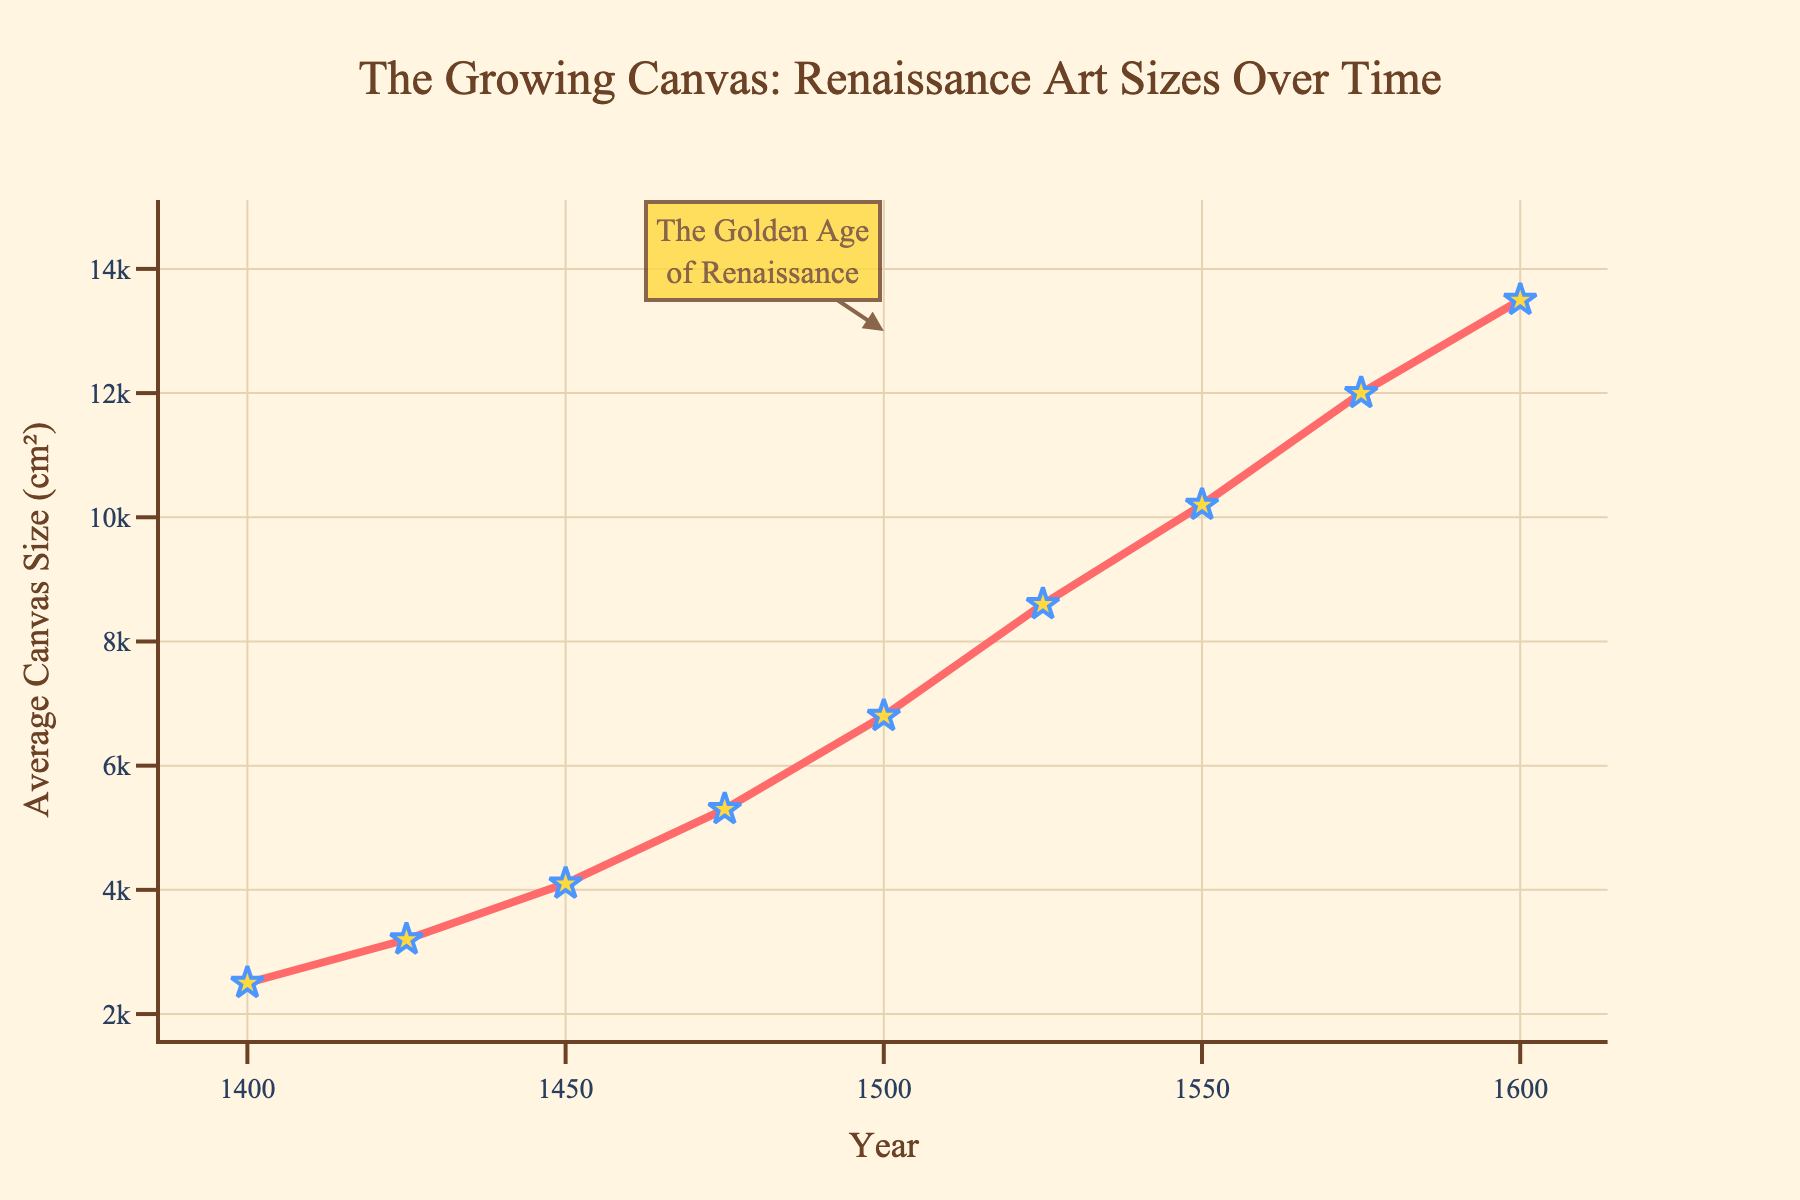What is the average canvas size in 1475? Check the data point on the line chart corresponding to the year 1475, which shows an average canvas size of 5300 cm².
Answer: 5300 cm² How much did the average canvas size increase between 1450 and 1500? Locate the data points for 1450 and 1500 in the chart. For 1450, the average size is 4100 cm²; for 1500, it is 6800 cm². Subtract the value of 1450 from 1500: 6800 - 4100 = 2700 cm².
Answer: 2700 cm² In what year did the average canvas size first exceed 8000 cm²? Scan the chart to identify the year where the average canvas size first crosses 8000 cm². It's between 1500 (6800 cm²) and 1525 (8600 cm²). Therefore, the year is 1525.
Answer: 1525 What was the difference in average canvas size from the beginning to the end of the period shown in the chart? Locate the initial size in 1400 (2500 cm²) and the final size in 1600 (13500 cm²). Subtract the initial from the final size: 13500 - 2500 = 11000 cm².
Answer: 11000 cm² By how much did the average canvas size grow from 1400 to 1475? Look for the data points corresponding to the years 1400 and 1475. The sizes are 2500 cm² and 5300 cm², respectively. Then, subtract the size in 1400 from the size in 1475: 5300 - 2500 = 2800 cm².
Answer: 2800 cm² What is the trend of the average canvas size from 1400 to 1600? Observe the line chart from 1400 to 1600, which shows a consistently increasing trend in average canvas size.
Answer: Increasing How much larger was the average canvas size in 1575 compared to 1450? Check the chart for data points of 1450 (4100 cm²) and 1575 (12000 cm²). Subtract the size at 1450 from the size at 1575: 12000 - 4100 = 7900 cm².
Answer: 7900 cm² What was the highest average canvas size recorded during the period shown in the chart? Identify the peak of the line chart, which occurs at 1600 with an average canvas size of 13500 cm².
Answer: 13500 cm² How many times did the average canvas size double from 1400 to 1600? The initial size in 1400 is 2500 cm². Doubling would be as follows: double once to 5000 cm², twice to 10000 cm², and thrice to 20000 cm² (not reached). Since 13500 falls between the second and third doubling, the size doubled twice.
Answer: Twice What is annotated as the "Golden Age of Renaissance" in the chart? The annotation in the chart labeled "The Golden Age of Renaissance" points to the period around the year 1500.
Answer: Around the year 1500 